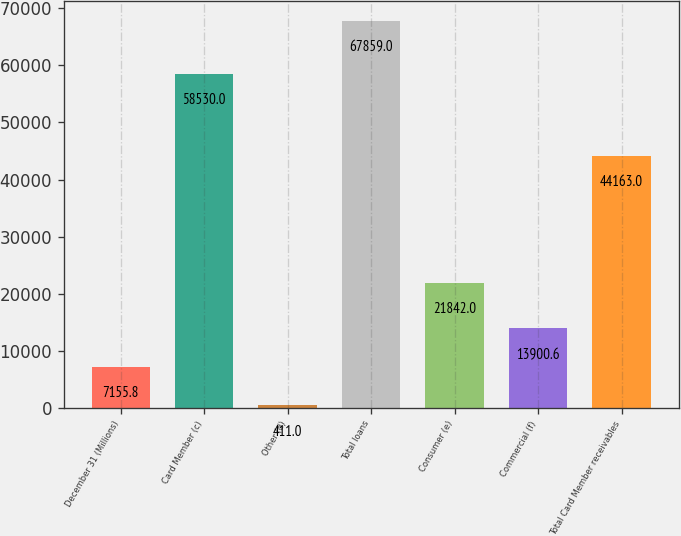<chart> <loc_0><loc_0><loc_500><loc_500><bar_chart><fcel>December 31 (Millions)<fcel>Card Member (c)<fcel>Other (d)<fcel>Total loans<fcel>Consumer (e)<fcel>Commercial (f)<fcel>Total Card Member receivables<nl><fcel>7155.8<fcel>58530<fcel>411<fcel>67859<fcel>21842<fcel>13900.6<fcel>44163<nl></chart> 